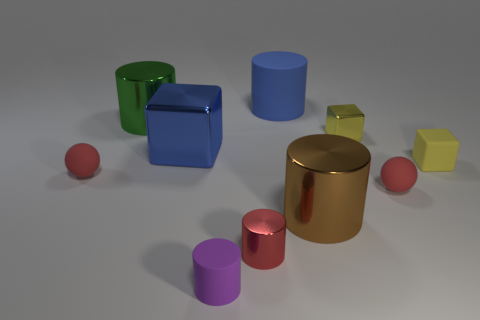Can you describe the geometrical shapes visible in the image? Certainly! The image features a variety of three-dimensional geometric shapes including cylinders, cubes, a sphere, and rectangular prisms. Specifically, there are several cylinders of different sizes and colors, a couple of cubes, and at least one sphere. The shapes are arranged on a flat surface, creating a visually interesting composition.  Which of the cylinders would you say is the tallest? The tallest cylinder in the image appears to be the brown metallic one located roughly in the center of the arrangement. It stands out due to its height and color. 